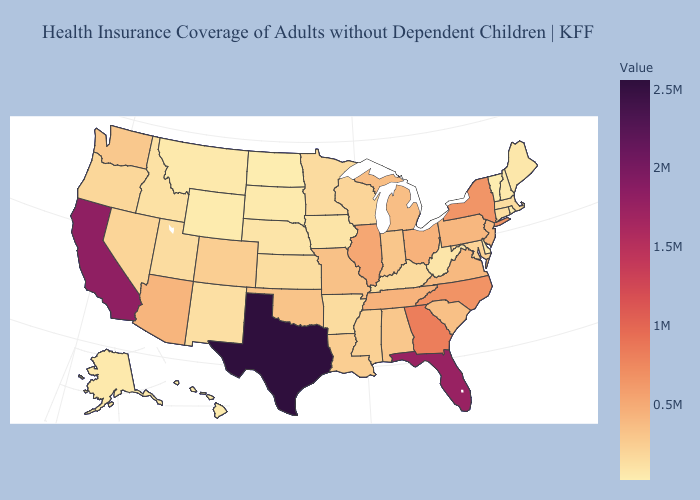Does Vermont have the lowest value in the USA?
Give a very brief answer. Yes. Does California have a lower value than Texas?
Short answer required. Yes. Does West Virginia have the highest value in the South?
Quick response, please. No. Which states have the lowest value in the West?
Write a very short answer. Wyoming. 